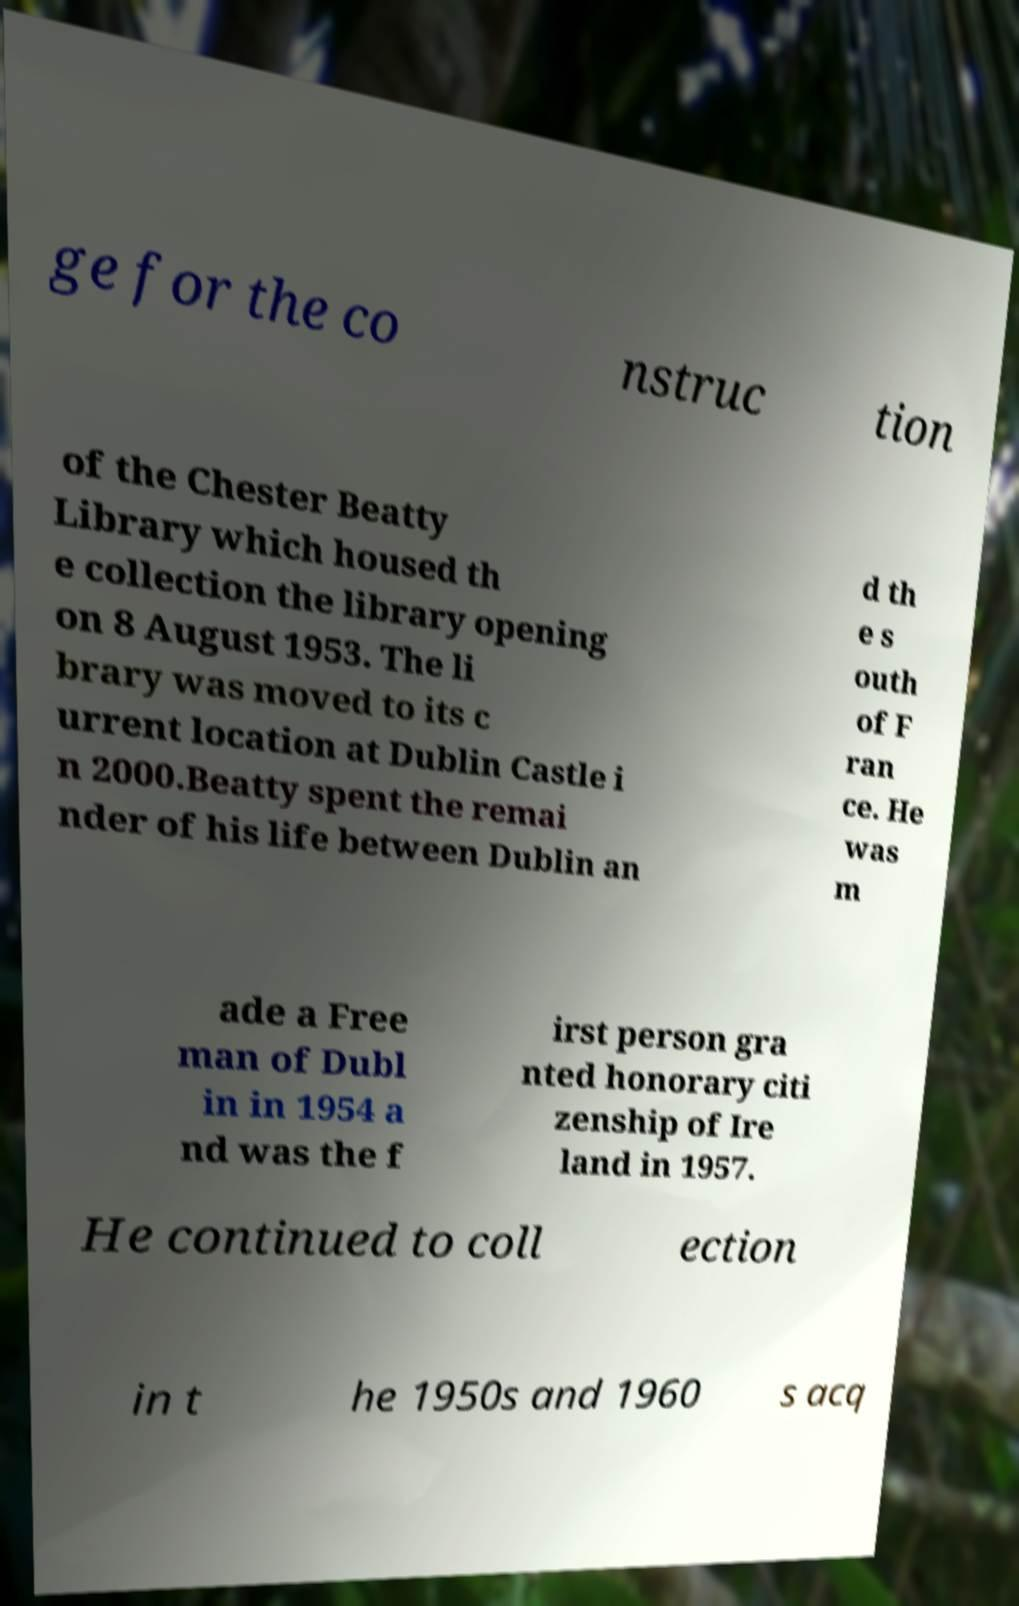Can you accurately transcribe the text from the provided image for me? ge for the co nstruc tion of the Chester Beatty Library which housed th e collection the library opening on 8 August 1953. The li brary was moved to its c urrent location at Dublin Castle i n 2000.Beatty spent the remai nder of his life between Dublin an d th e s outh of F ran ce. He was m ade a Free man of Dubl in in 1954 a nd was the f irst person gra nted honorary citi zenship of Ire land in 1957. He continued to coll ection in t he 1950s and 1960 s acq 